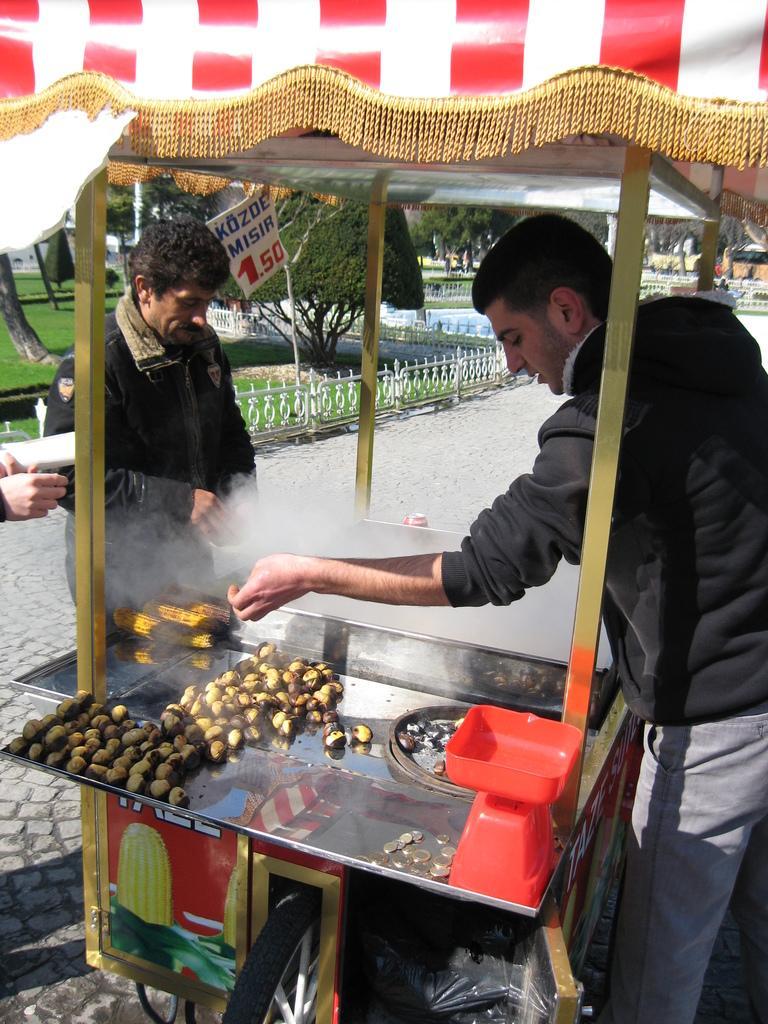How would you summarize this image in a sentence or two? In the picture I can see a food stall vehicle on the road. There is a man on the right side is wearing a black color jacket. I can see the corn in the vehicle. There is another man on the left side. In the background, I can see the trees and metal fence. 